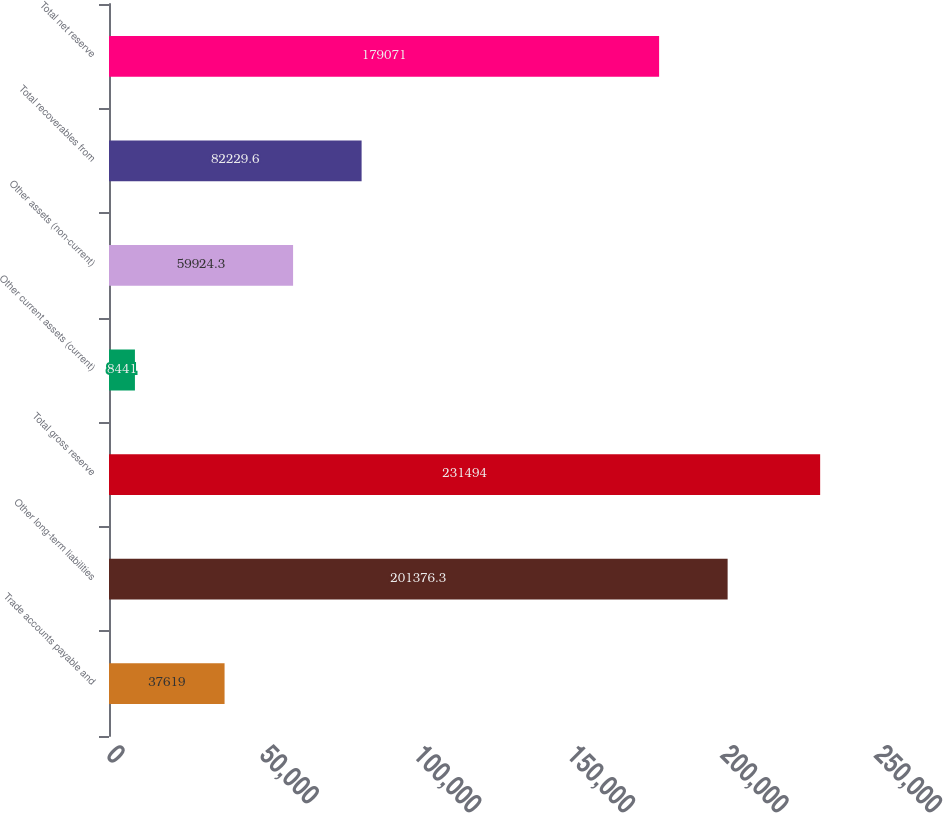Convert chart. <chart><loc_0><loc_0><loc_500><loc_500><bar_chart><fcel>Trade accounts payable and<fcel>Other long-term liabilities<fcel>Total gross reserve<fcel>Other current assets (current)<fcel>Other assets (non-current)<fcel>Total recoverables from<fcel>Total net reserve<nl><fcel>37619<fcel>201376<fcel>231494<fcel>8441<fcel>59924.3<fcel>82229.6<fcel>179071<nl></chart> 